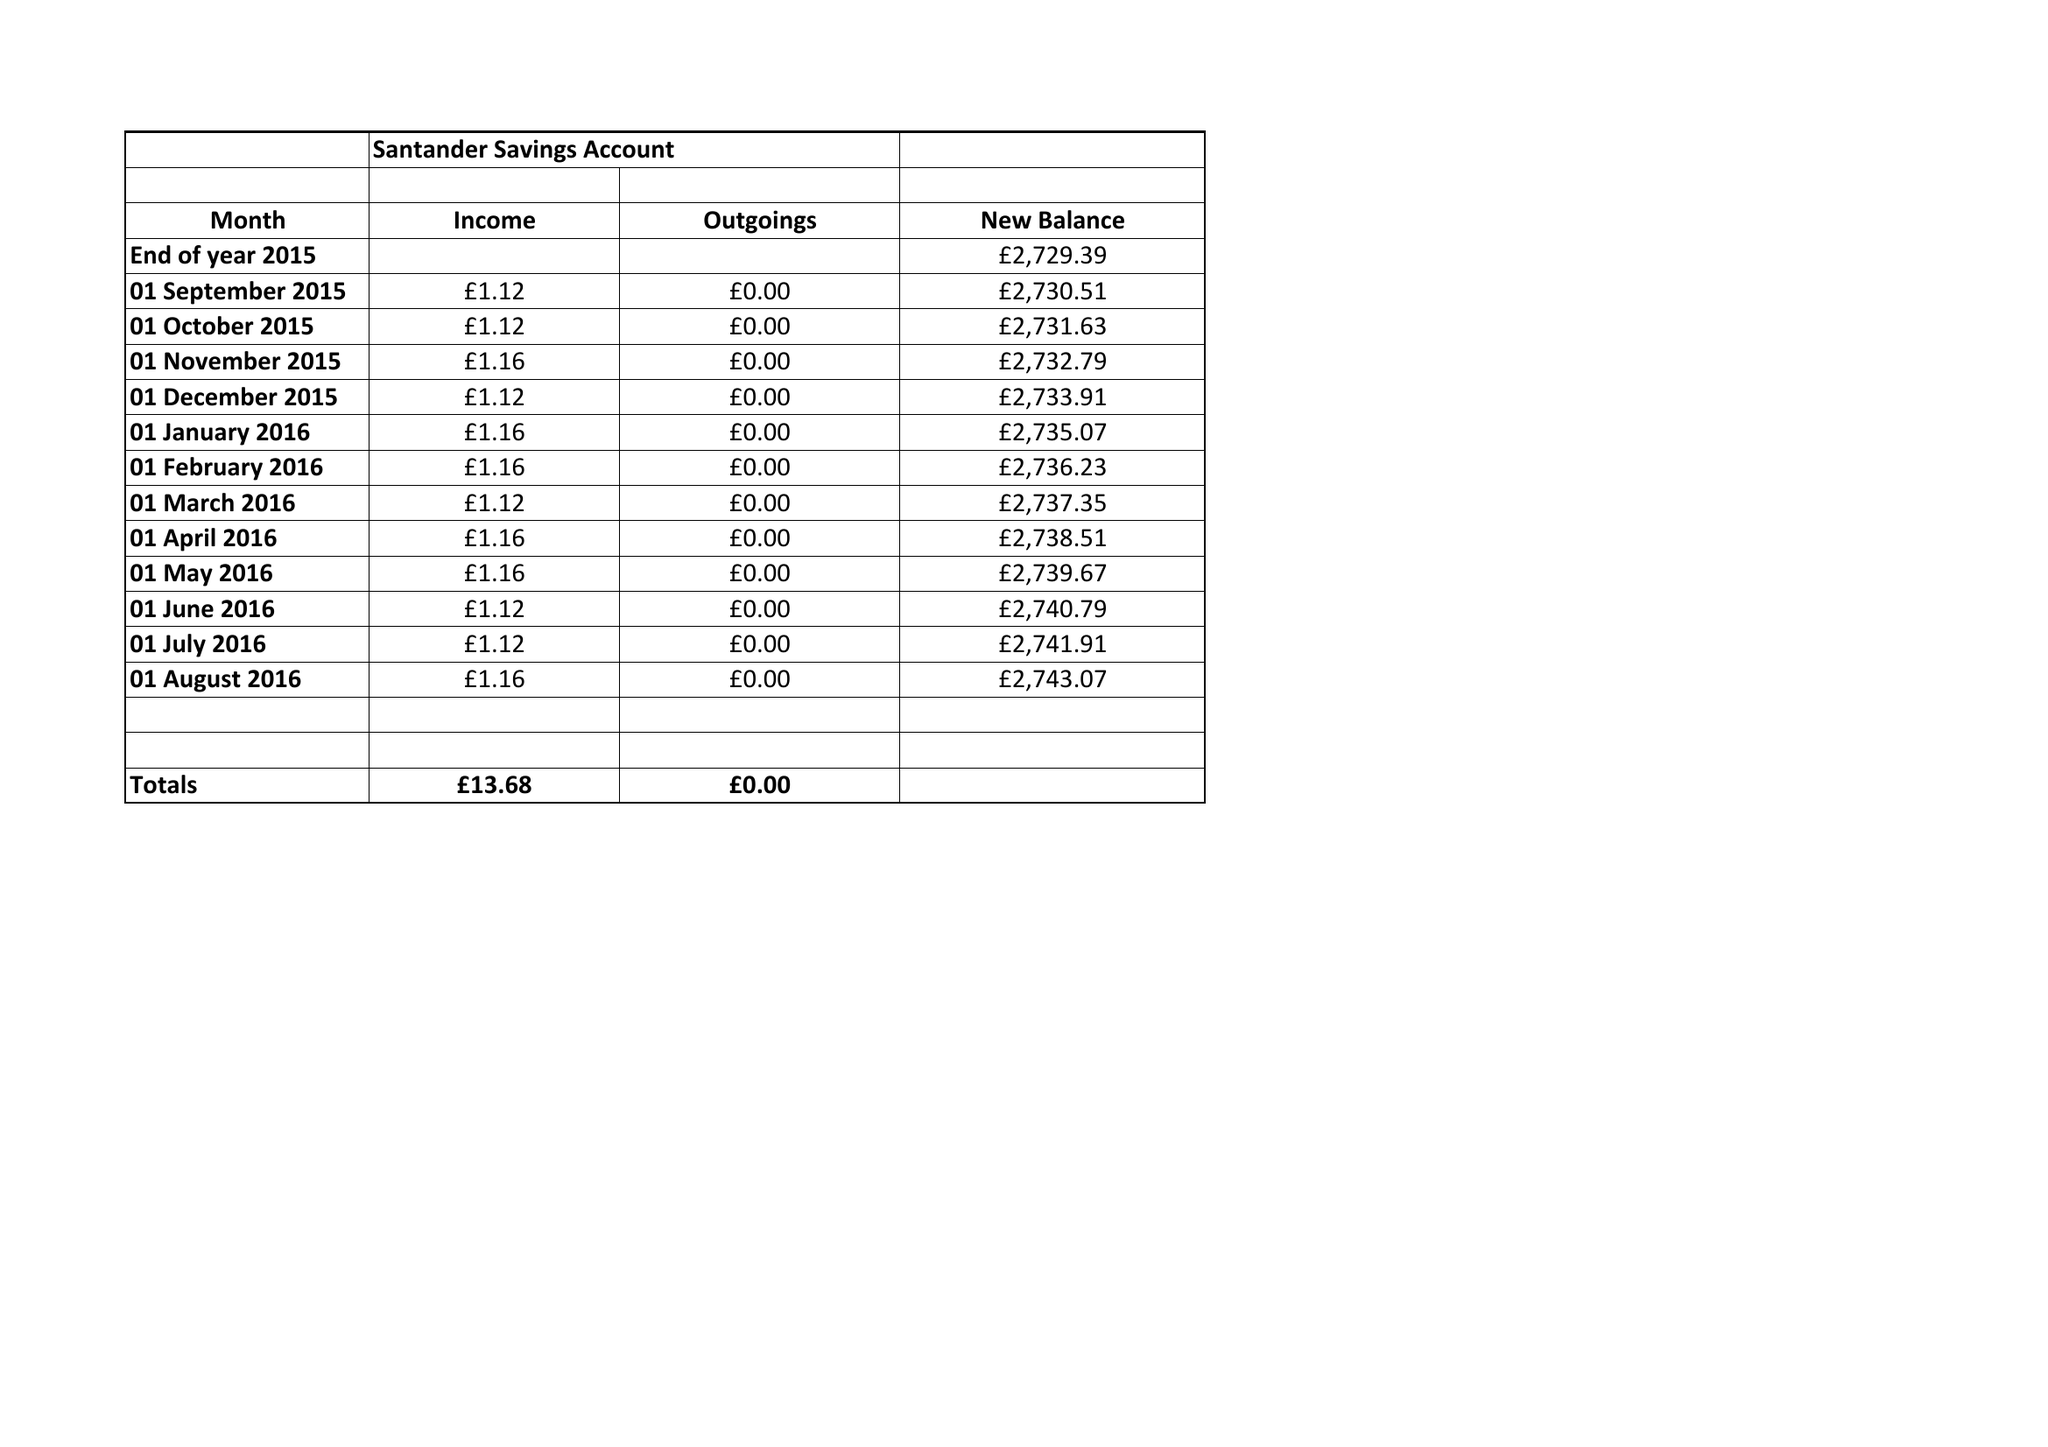What is the value for the address__postcode?
Answer the question using a single word or phrase. None 